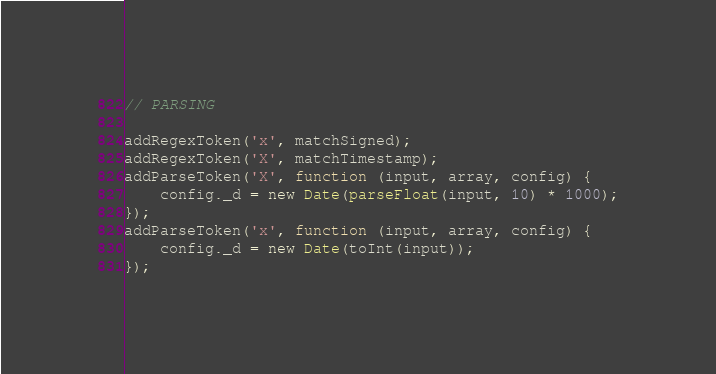Convert code to text. <code><loc_0><loc_0><loc_500><loc_500><_JavaScript_>
// PARSING

addRegexToken('x', matchSigned);
addRegexToken('X', matchTimestamp);
addParseToken('X', function (input, array, config) {
    config._d = new Date(parseFloat(input, 10) * 1000);
});
addParseToken('x', function (input, array, config) {
    config._d = new Date(toInt(input));
});</code> 